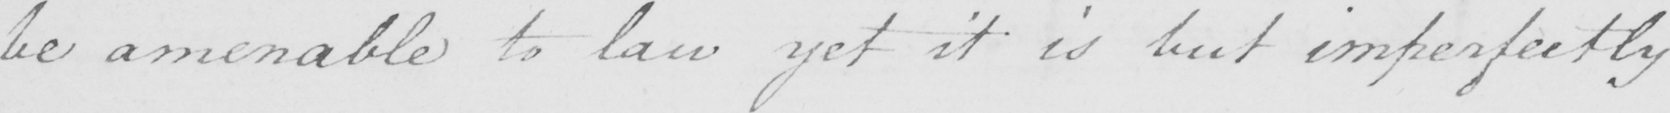Transcribe the text shown in this historical manuscript line. be amenable to law yet it is but imperfectly 